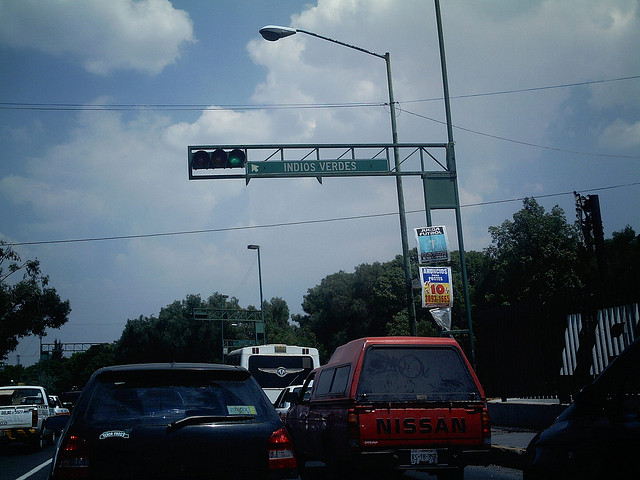Extract all visible text content from this image. NISSAN 1 INDIOS VERDES 10 IP 